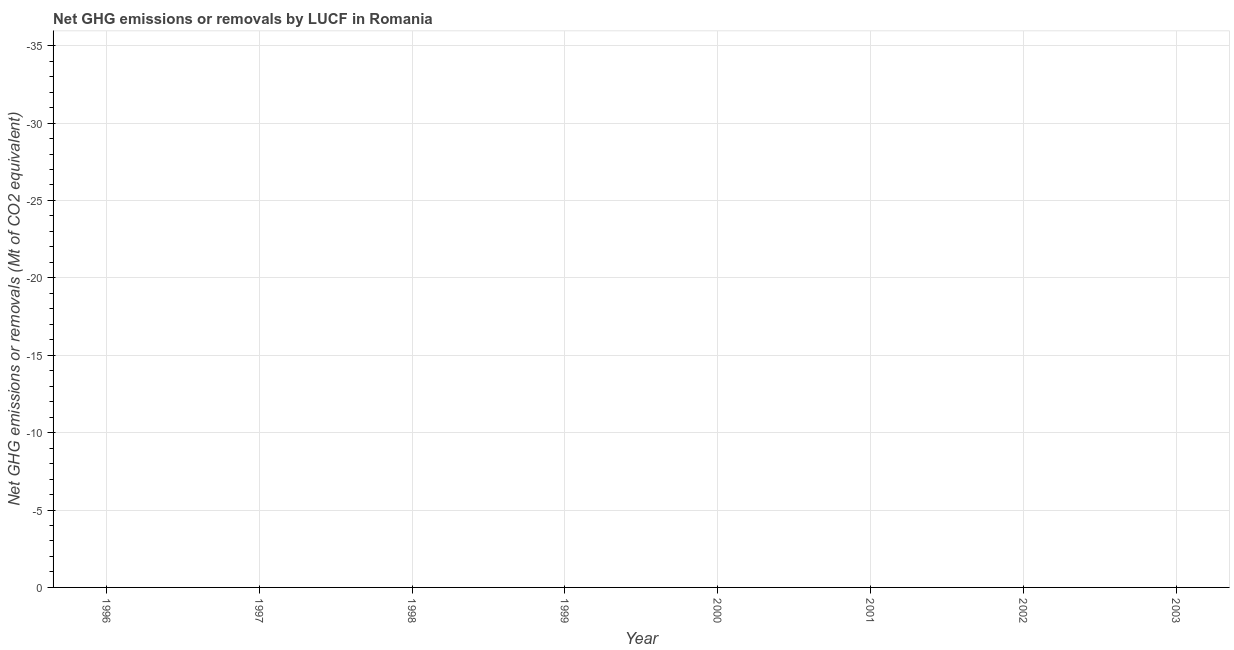What is the ghg net emissions or removals in 2001?
Make the answer very short. 0. What is the sum of the ghg net emissions or removals?
Give a very brief answer. 0. What is the median ghg net emissions or removals?
Your response must be concise. 0. In how many years, is the ghg net emissions or removals greater than -34 Mt?
Offer a terse response. 0. Does the graph contain grids?
Your answer should be very brief. Yes. What is the title of the graph?
Make the answer very short. Net GHG emissions or removals by LUCF in Romania. What is the label or title of the X-axis?
Your response must be concise. Year. What is the label or title of the Y-axis?
Provide a short and direct response. Net GHG emissions or removals (Mt of CO2 equivalent). What is the Net GHG emissions or removals (Mt of CO2 equivalent) of 2000?
Your answer should be very brief. 0. What is the Net GHG emissions or removals (Mt of CO2 equivalent) in 2003?
Make the answer very short. 0. 